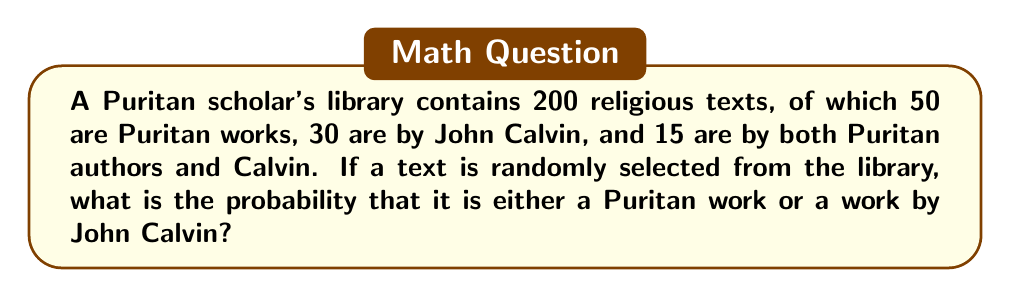What is the answer to this math problem? To solve this problem, we'll use the principle of inclusion-exclusion from set theory. Let's break it down step-by-step:

1) Let A be the event of selecting a Puritan work, and B be the event of selecting a work by John Calvin.

2) We need to find P(A ∪ B), the probability of selecting either a Puritan work or a work by Calvin.

3) The formula for the union of two sets is:
   P(A ∪ B) = P(A) + P(B) - P(A ∩ B)

4) Calculate P(A):
   P(A) = 50/200 = 1/4

5) Calculate P(B):
   P(B) = 30/200 = 3/20

6) Calculate P(A ∩ B):
   P(A ∩ B) = 15/200 = 3/40

7) Now, let's apply the formula:
   P(A ∪ B) = P(A) + P(B) - P(A ∩ B)
            = 1/4 + 3/20 - 3/40

8) To add these fractions, we need a common denominator of 40:
   P(A ∪ B) = 10/40 + 6/40 - 3/40
            = 13/40

Therefore, the probability of selecting either a Puritan work or a work by John Calvin is 13/40.
Answer: $\frac{13}{40}$ or $0.325$ or $32.5\%$ 